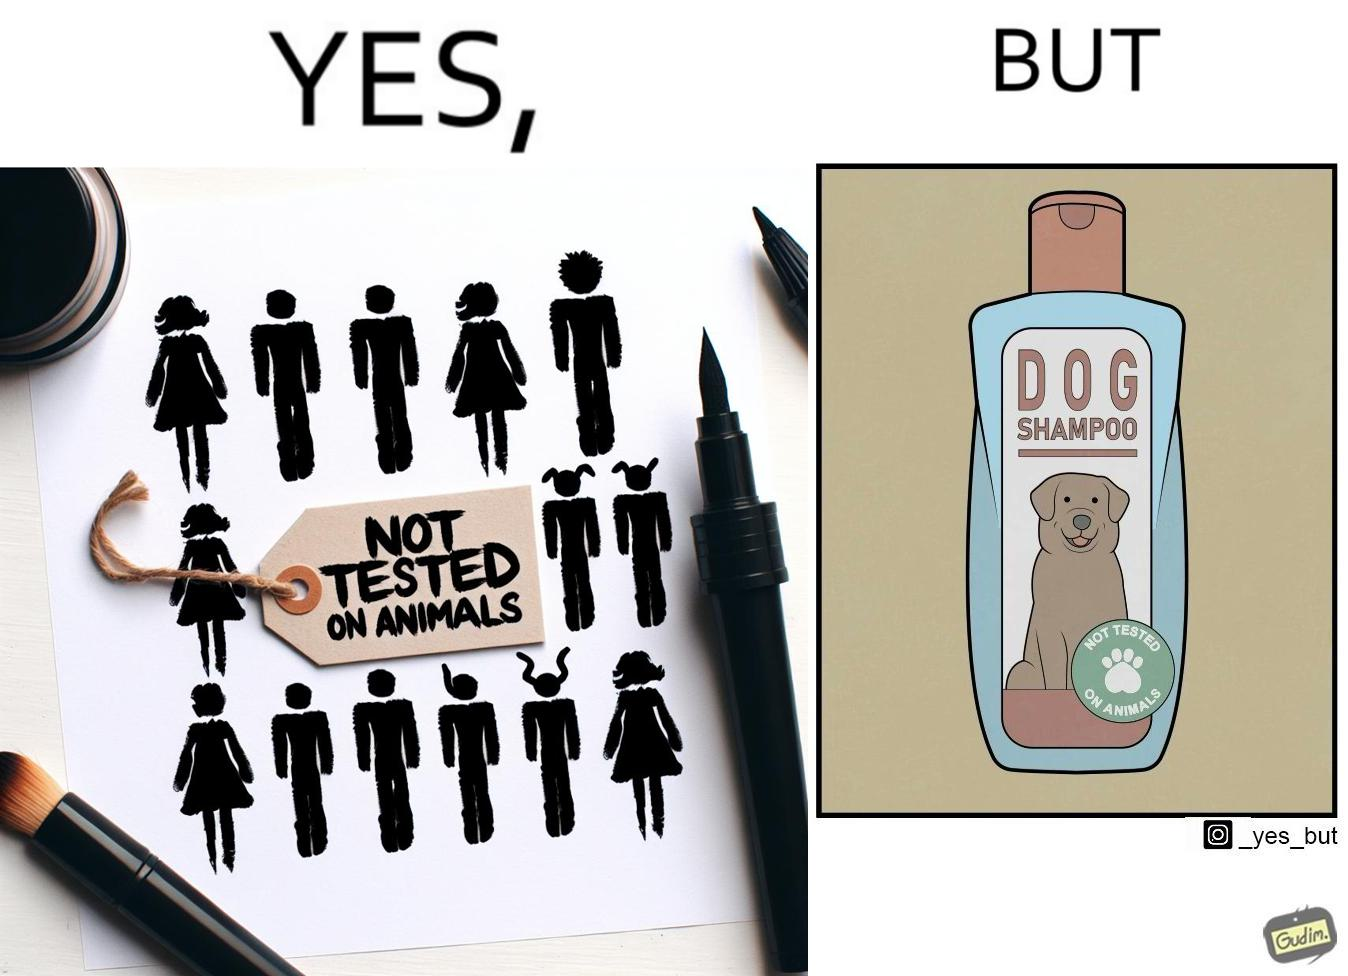What do you see in each half of this image? In the left part of the image: It is a tag saying "not tested on animals" In the right part of the image: It is a dog shampoo bottle. 